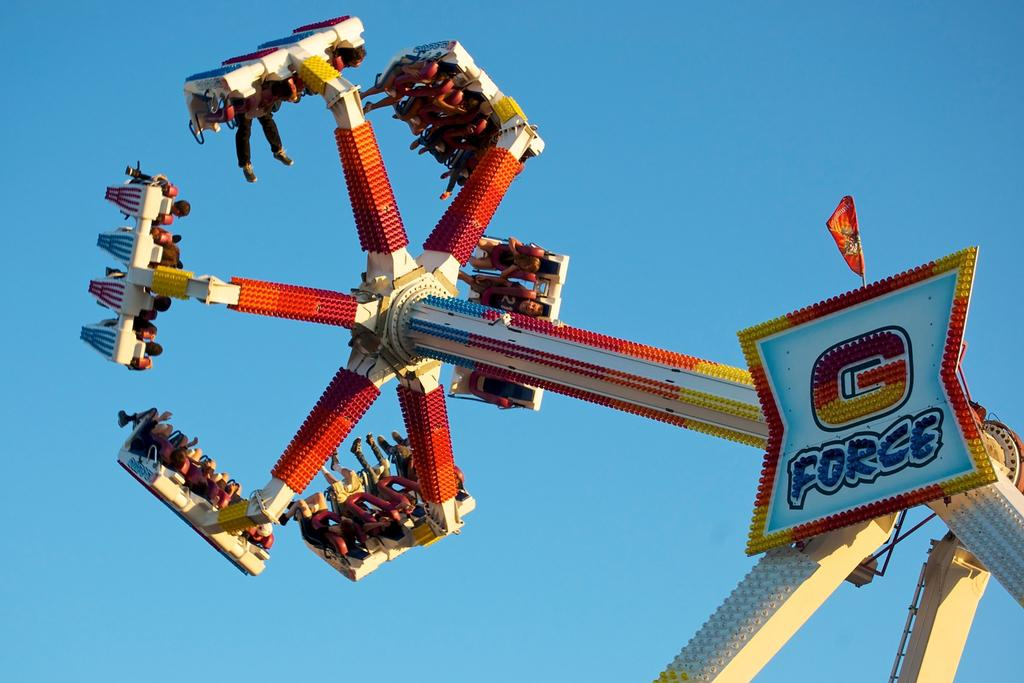What is the main subject in the center of the image? There is an amusement ride in the center of the image. What else can be seen in the image besides the amusement ride? There is a banner and a flag in the image. What are the people in the image doing? There are people sitting on the amusement ride. What can be seen in the background of the image? The sky is visible in the background of the image. What type of straw is being used by the people on the amusement ride? There is no straw visible in the image, as it features an amusement ride, a banner, a flag, and people sitting on the ride. 